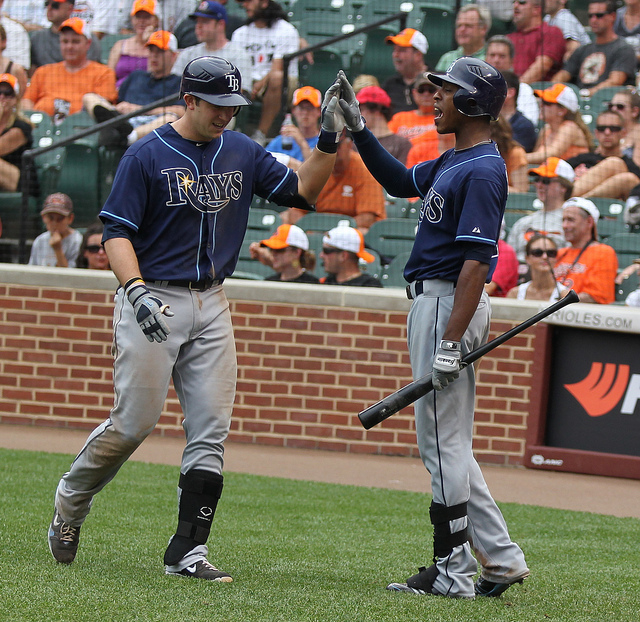<image>What bank name can be seen? There is no bank name that can be seen in the image. What bank name can be seen? I am not sure what bank name can be seen. There are multiple options like 'usaa', 'rays', 'chase', and 'huntington'. 